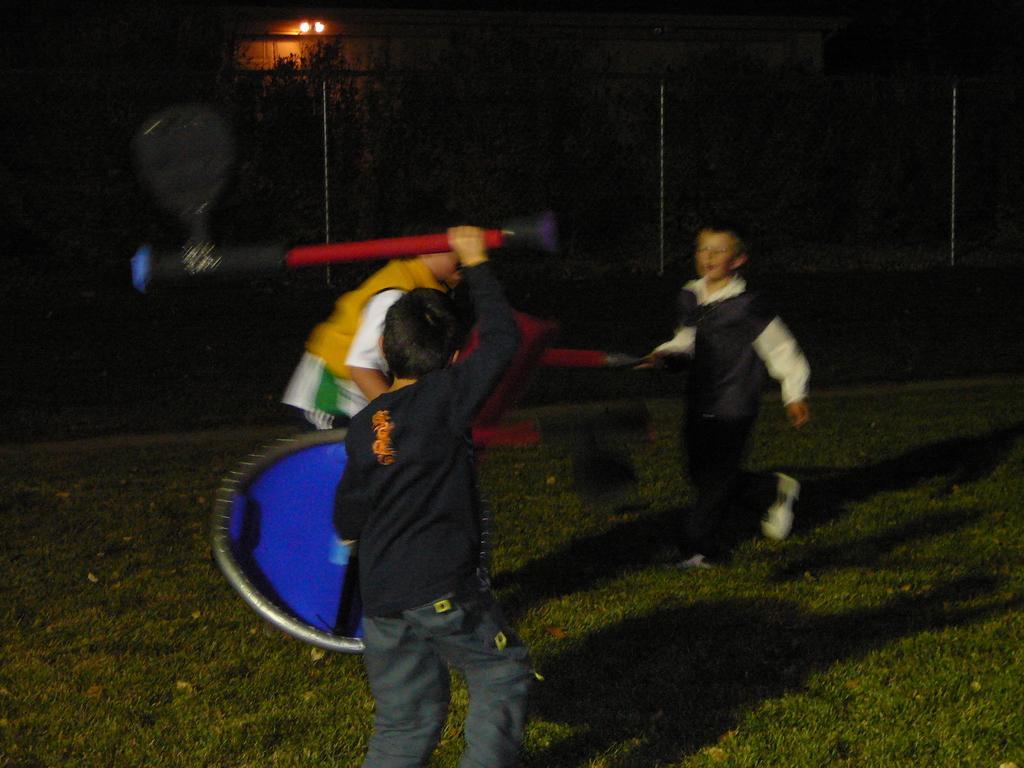Could you give a brief overview of what you see in this image? In this picture we can see there are two people holding some objects and a person is standing on an object and the object is on the grass. Behind the people there is the fence, trees, lights and a house. 